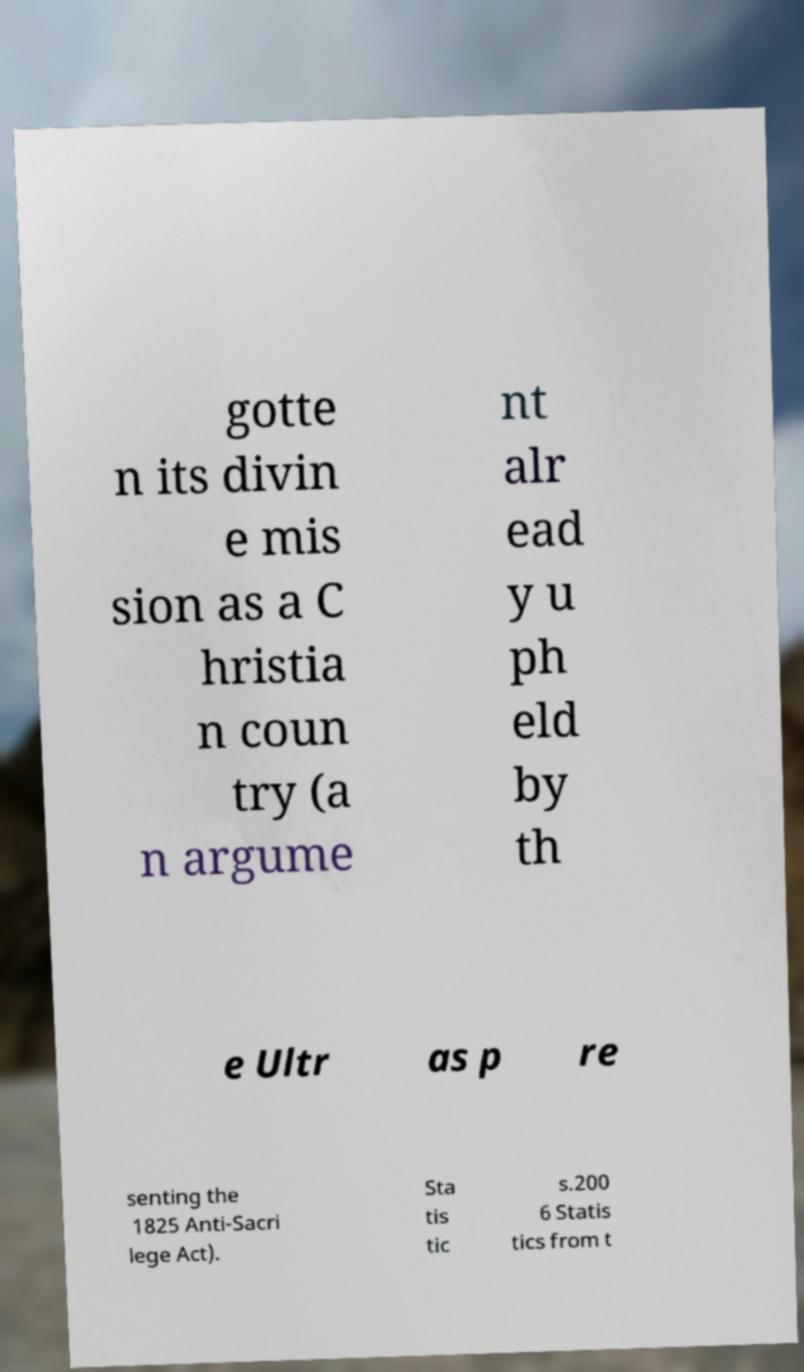Could you assist in decoding the text presented in this image and type it out clearly? gotte n its divin e mis sion as a C hristia n coun try (a n argume nt alr ead y u ph eld by th e Ultr as p re senting the 1825 Anti-Sacri lege Act). Sta tis tic s.200 6 Statis tics from t 